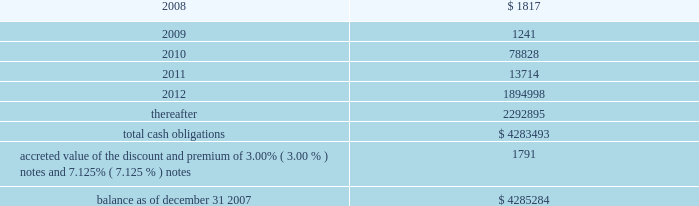American tower corporation and subsidiaries notes to consolidated financial statements 2014 ( continued ) maturities 2014as of december 31 , 2007 , aggregate carrying value of long-term debt , including capital leases , for the next five years and thereafter are estimated to be ( in thousands ) : year ending december 31 .
Acquisitions during the years ended december 31 , 2007 , 2006 and 2005 , the company used cash to acquire a total of ( i ) 293 towers and the assets of a structural analysis firm for approximately $ 44.0 million in cash ( ii ) 84 towers and 6 in-building distributed antenna systems for approximately $ 14.3 million and ( iii ) 30 towers for approximately $ 6.0 million in cash , respectively .
The tower asset acquisitions were primarily in mexico and brazil under ongoing agreements .
During the year ended december 31 , 2005 , the company also completed its merger with spectrasite , inc .
Pursuant to which the company acquired approximately 7800 towers and 100 in-building distributed antenna systems .
Under the terms of the merger agreement , in august 2005 , spectrasite , inc .
Merged with a wholly- owned subsidiary of the company , and each share of spectrasite , inc .
Common stock converted into the right to receive 3.575 shares of the company 2019s class a common stock .
The company issued approximately 169.5 million shares of its class a common stock and reserved for issuance approximately 9.9 million and 6.8 million of class a common stock pursuant to spectrasite , inc .
Options and warrants , respectively , assumed in the merger .
The final allocation of the $ 3.1 billion purchase price is summarized in the company 2019s annual report on form 10-k for the year ended december 31 , 2006 .
The acquisitions consummated by the company during 2007 , 2006 and 2005 , have been accounted for under the purchase method of accounting in accordance with sfas no .
141 201cbusiness combinations 201d ( sfas no .
141 ) .
The purchase prices have been allocated to the net assets acquired and the liabilities assumed based on their estimated fair values at the date of acquisition .
The company primarily acquired its tower assets from third parties in one of two types of transactions : the purchase of a business or the purchase of assets .
The structure of each transaction affects the way the company allocates purchase price within the consolidated financial statements .
In the case of tower assets acquired through the purchase of a business , such as the company 2019s merger with spectrasite , inc. , the company allocates the purchase price to the assets acquired and liabilities assumed at their estimated fair values as of the date of acquisition .
The excess of the purchase price paid by the company over the estimated fair value of net assets acquired has been recorded as goodwill .
In the case of an asset purchase , the company first allocates the purchase price to property and equipment for the appraised value of the towers and to identifiable intangible assets ( primarily acquired customer base ) .
The company then records any remaining purchase price within intangible assets as a 201cnetwork location intangible . 201d .
What is the total expected payments related to long-term debt , including capital leases in the next 24 months , in thousands? 
Computations: (1817 + 1241)
Answer: 3058.0. 